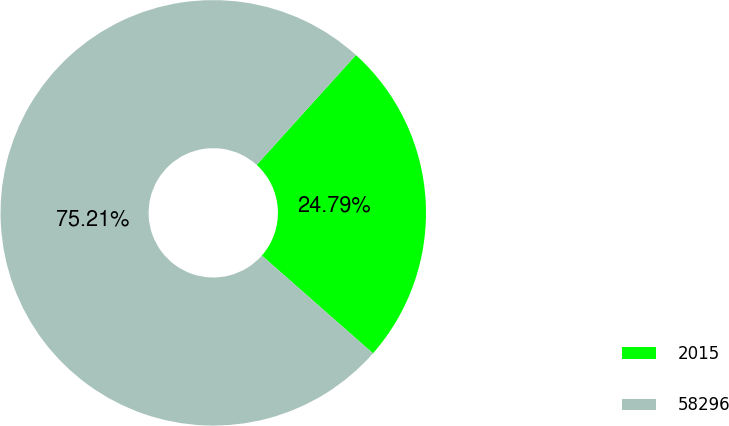Convert chart. <chart><loc_0><loc_0><loc_500><loc_500><pie_chart><fcel>2015<fcel>58296<nl><fcel>24.79%<fcel>75.21%<nl></chart> 